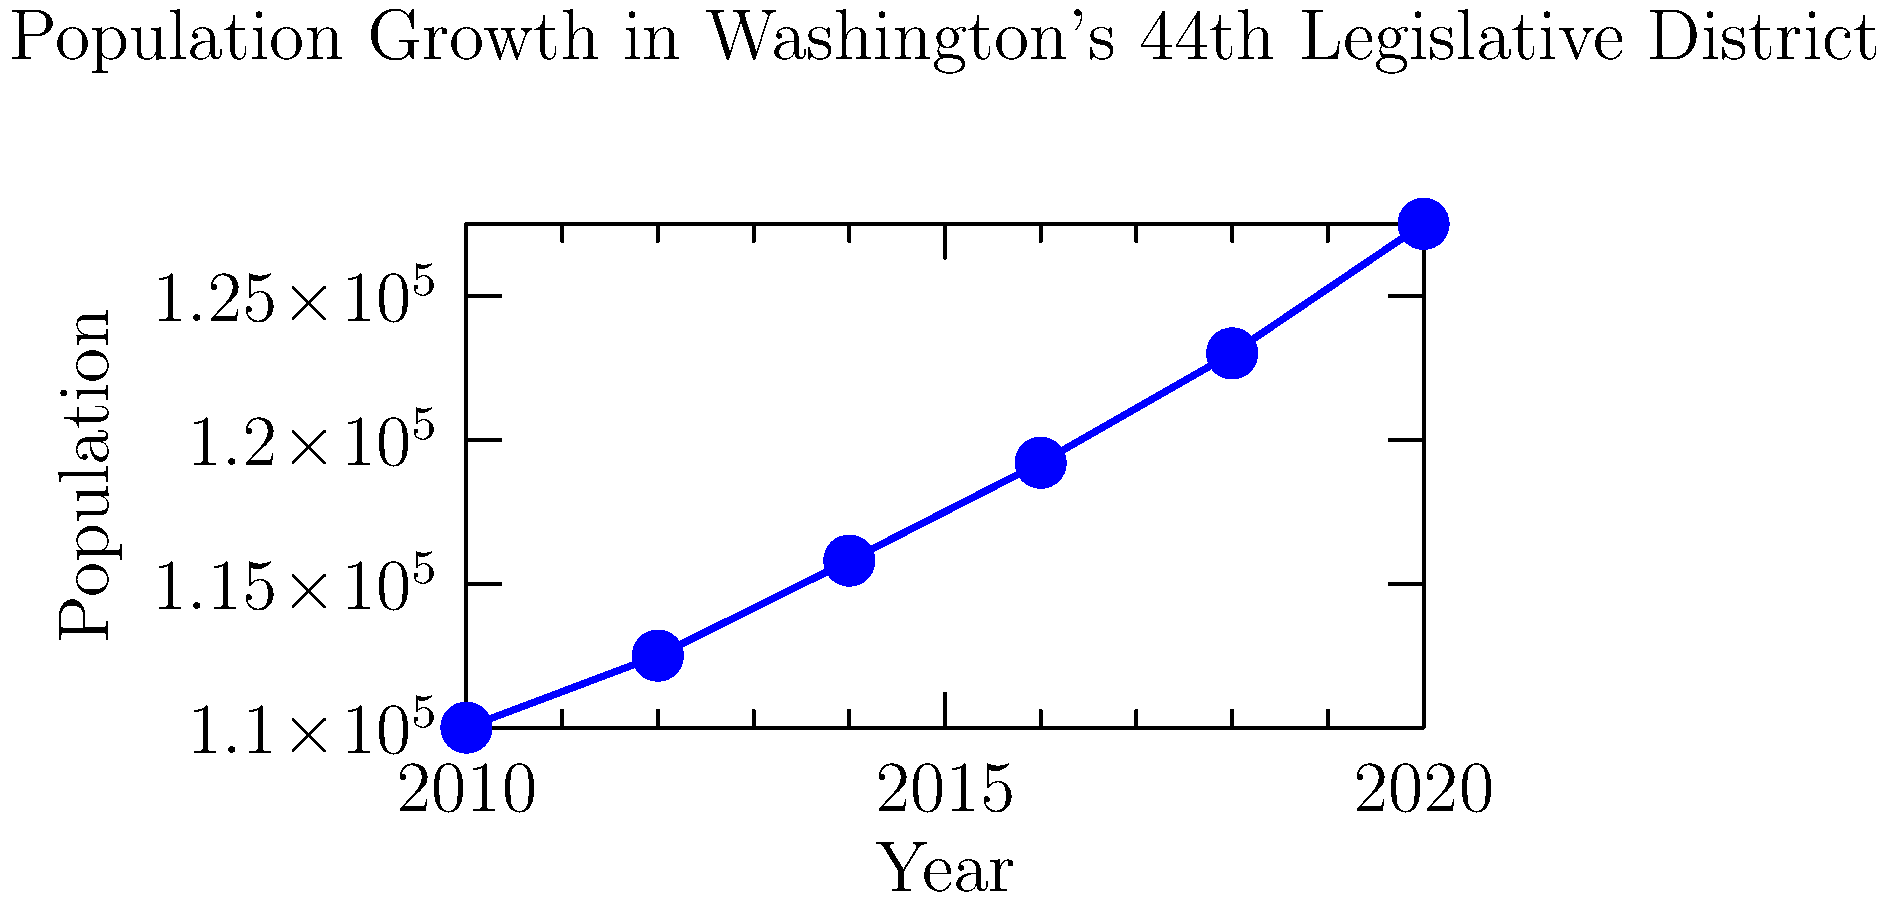Based on the line graph showing population growth in Washington's 44th Legislative District from 2010 to 2020, what was the approximate total population increase during this period? To find the total population increase from 2010 to 2020:

1. Identify the population in 2010: 110,000
2. Identify the population in 2020: 127,500
3. Calculate the difference:
   $127,500 - 110,000 = 17,500$

The total population increase from 2010 to 2020 was approximately 17,500 people.

This information is relevant to local voters in the 44th Legislative District as it demonstrates significant population growth, which can impact various aspects of local governance, infrastructure needs, and representation.
Answer: 17,500 people 